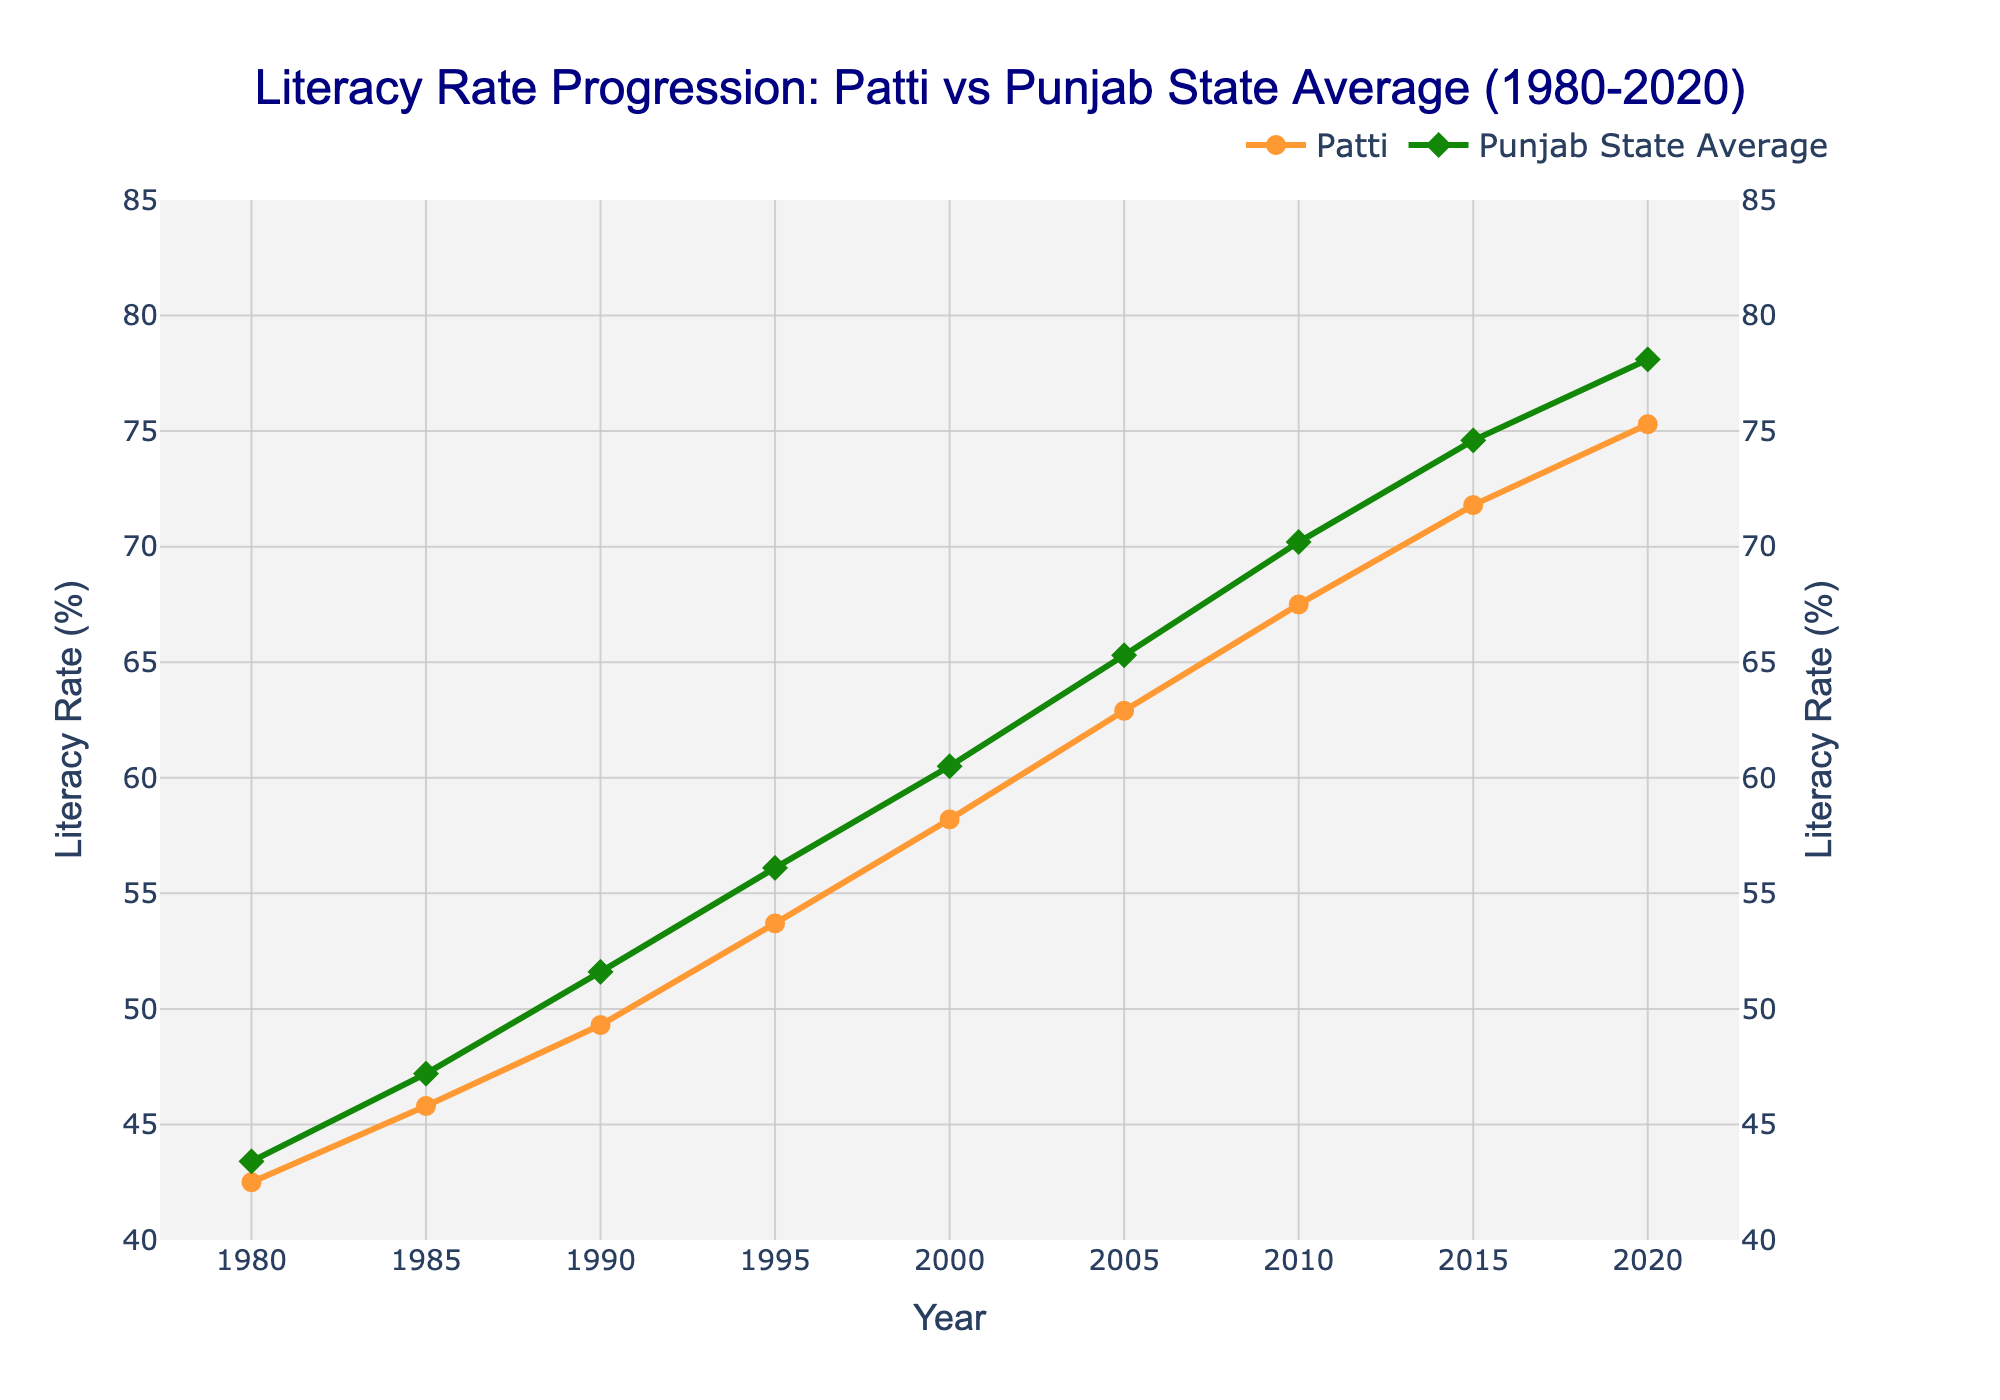What is the difference in literacy rate between Patti and Punjab state average in 1980? In 1980, the literacy rate for Patti is 42.5%, and the state average is 43.4%. The difference is calculated as 43.4% - 42.5%.
Answer: 0.9% What year did Patti's literacy rate first surpass 50%? By examining the Patti literacy rates, it first exceeds 50% in the data for the year 1990 (49.3% to 53.7%).
Answer: 1995 Which year saw the highest increase in literacy rate for Patti compared to the previous year? Calculate the year-over-year increase in literacy rates for Patti. The highest increase is noted between 1985 (45.8%) and 1990 (49.3%). The increase is 49.3% - 45.8% = 3.5%.
Answer: 1985-1990 How did the literacy rates for Patti and Punjab change between 2000 and 2010? Review the literacy rate for 2000 and 2010. Patti increased from 58.2% to 67.5%, which is an increase of 9.3%. Punjab's rate went from 60.5% to 70.2%, an increase of 9.7%.
Answer: Patti: +9.3%, Punjab: +9.7% What is the visual difference in markers used for Patti and Punjab lines on the plot? In the plot, Patti's literacy rate has circle markers, while Punjab's state average has diamond markers.
Answer: Circle for Patti, Diamond for Punjab In which year did both Patti and Punjab's literacy rates cross 65%? Both Patti and Punjab's literacy rates exceeded 65%. Patti's rate crossed 65% in 2005 (62.9% to 67.5%). Punjab's rate crossed 65% in 2005 (65.3% to 70.2%).
Answer: 2010 Compare the literacy rates of Patti and Punjab in 2020. Which one is higher? Look at the 2020 data, where Patti’s literacy rate is 75.3%, and Punjab's state average is 78.1%. Therefore, Punjab's literacy rate is higher.
Answer: Punjab What is the average literacy rate of Patti from 1980 to 2020? Calculate the average: Sum the literacy rates of Patti from 1980 to 2020 and divide by the number of years. ((42.5+45.8+49.3+53.7+58.2+62.9+67.5+71.8+75.3) / 9) = 58.67%
Answer: 58.67% What interval shows the smallest growth in Punjab's literacy rate? Calculate the year-over-year increase and compare: smallest growth is between 2005 (65.3%) and 2010 (70.2%), an increase of 4.9%.
Answer: 2005-2010 How does the trend in literacy rate for Patti compare visually to the Punjab state average over the 40-year period? Both Patti and Punjab show an increasing trend in literacy rates from 1980 to 2020. Visually, the slope of Punjab’s line appears steeper in the initial years, indicating faster growth, but both trends follow a similar pattern.
Answer: Both increase, Punjab initially faster 